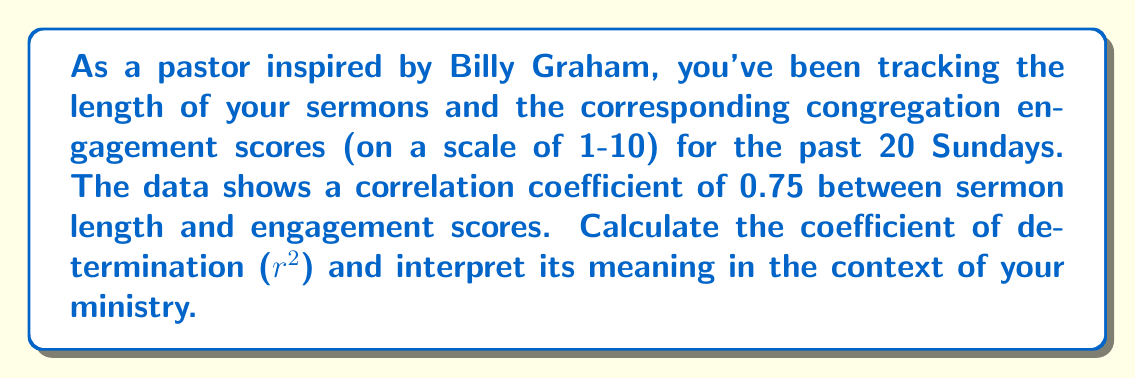Can you answer this question? To solve this problem, we'll follow these steps:

1) The correlation coefficient (r) is given as 0.75.

2) The coefficient of determination ($r^2$) is calculated by squaring the correlation coefficient:

   $r^2 = (0.75)^2 = 0.5625$

3) Interpretation:
   The coefficient of determination ($r^2$) represents the proportion of the variance in the dependent variable (congregation engagement) that is predictable from the independent variable (sermon length).

   In this case, $r^2 = 0.5625$ or 56.25%

   This means that approximately 56.25% of the variance in congregation engagement can be explained by the length of the sermons.

4) In the context of ministry:
   This result suggests that sermon length has a moderate to strong influence on congregation engagement. However, it also indicates that other factors (accounting for the remaining 43.75% of variance) also play a significant role in determining engagement levels.

   As a pastor, this information could be valuable for planning sermons and understanding the impact of sermon length on your congregation's engagement. However, it's important to consider other factors that might contribute to engagement as well.
Answer: $r^2 = 0.5625$; 56.25% of variance in engagement explained by sermon length 